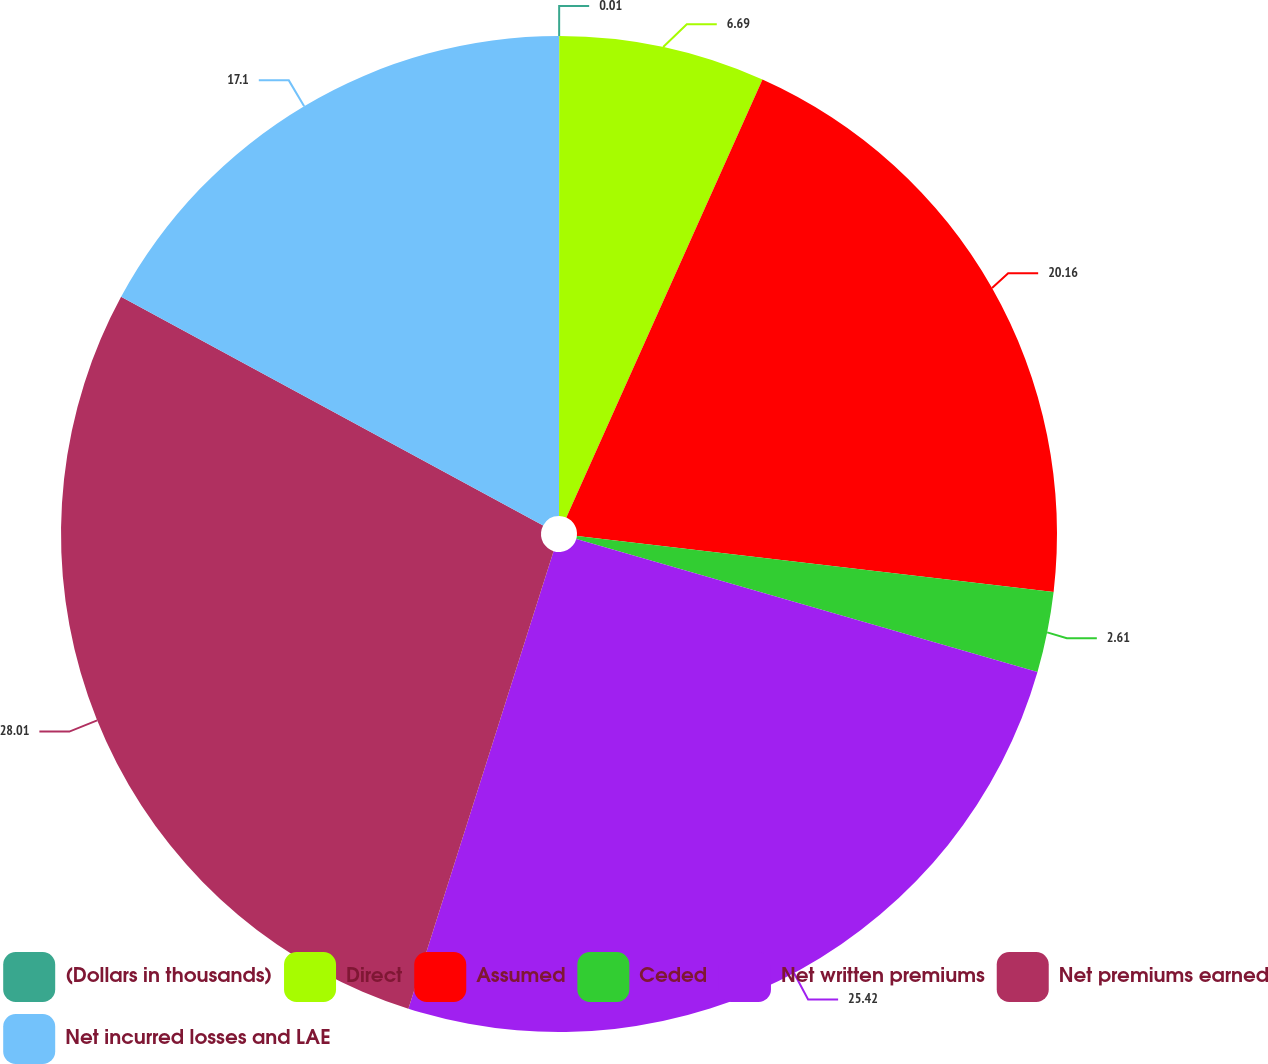Convert chart to OTSL. <chart><loc_0><loc_0><loc_500><loc_500><pie_chart><fcel>(Dollars in thousands)<fcel>Direct<fcel>Assumed<fcel>Ceded<fcel>Net written premiums<fcel>Net premiums earned<fcel>Net incurred losses and LAE<nl><fcel>0.01%<fcel>6.69%<fcel>20.16%<fcel>2.61%<fcel>25.42%<fcel>28.01%<fcel>17.1%<nl></chart> 